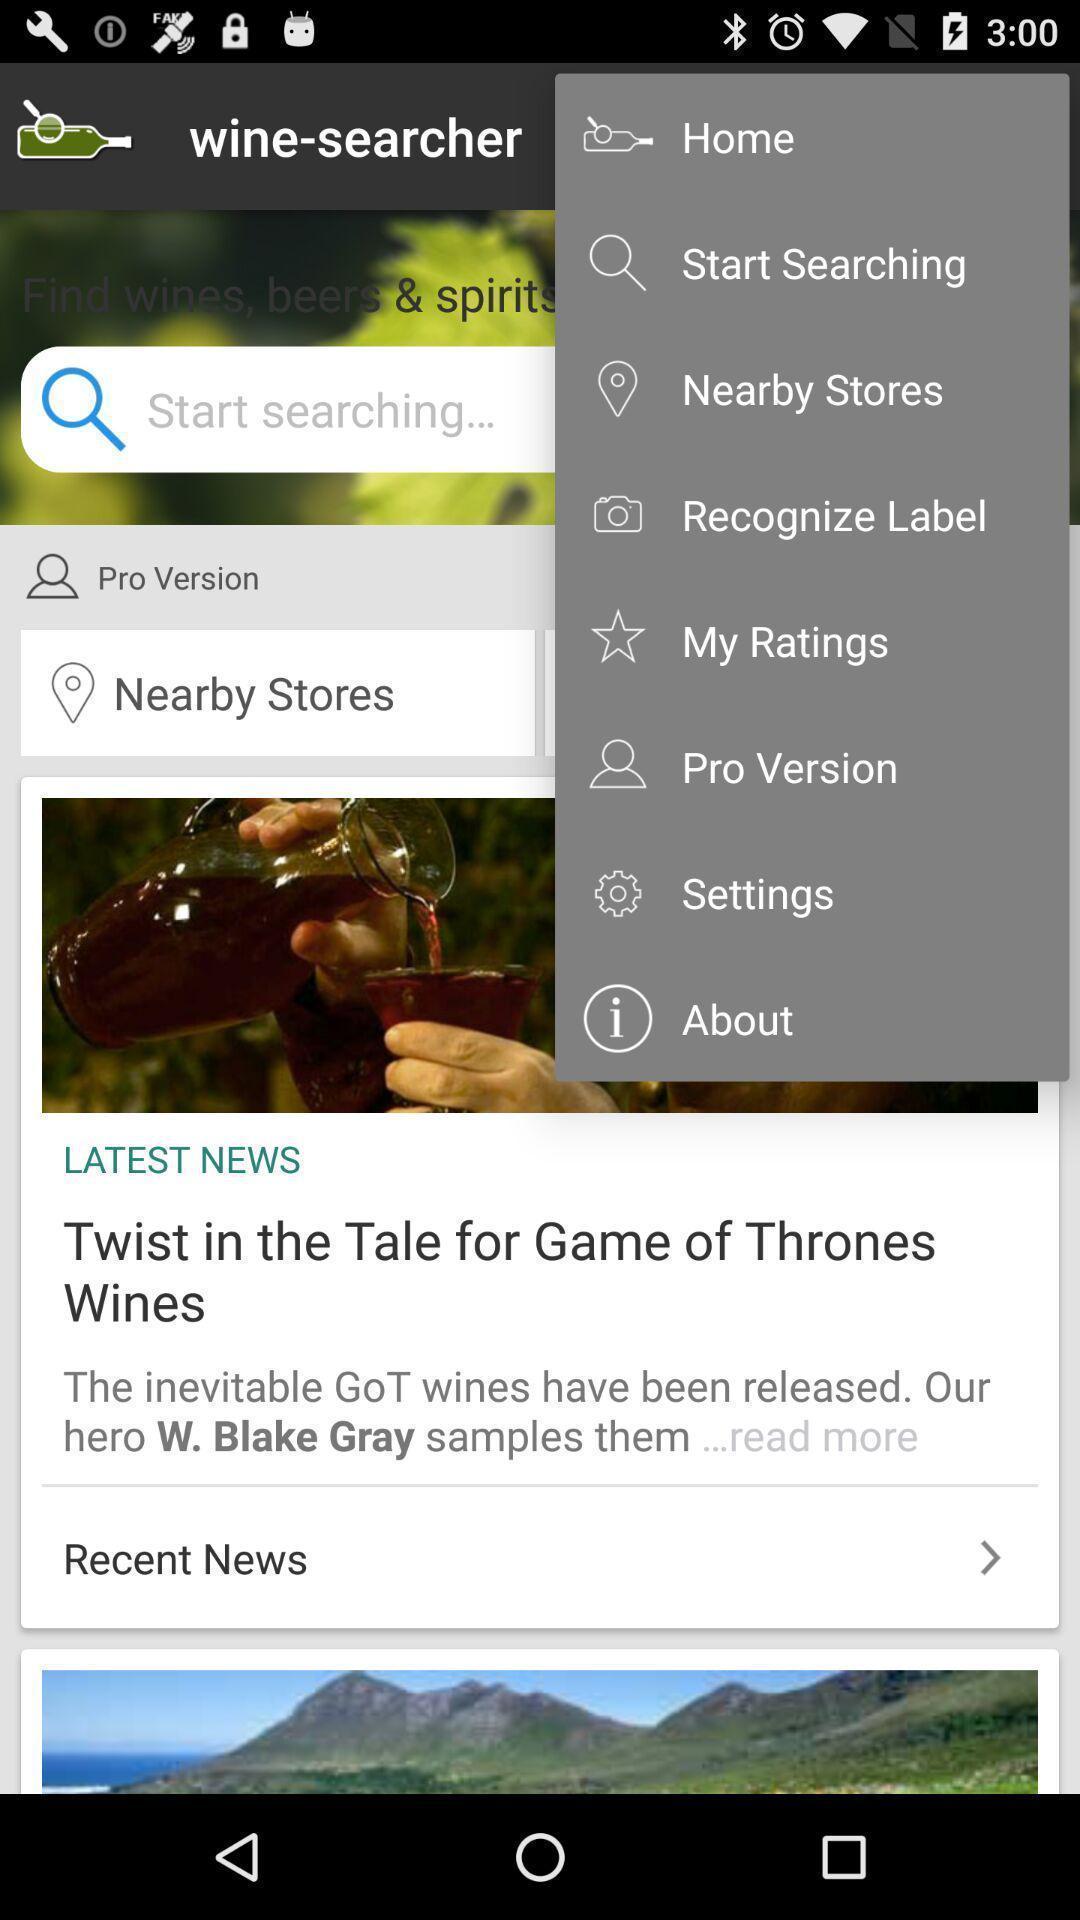Describe the visual elements of this screenshot. Screen shows different options in a news app. 